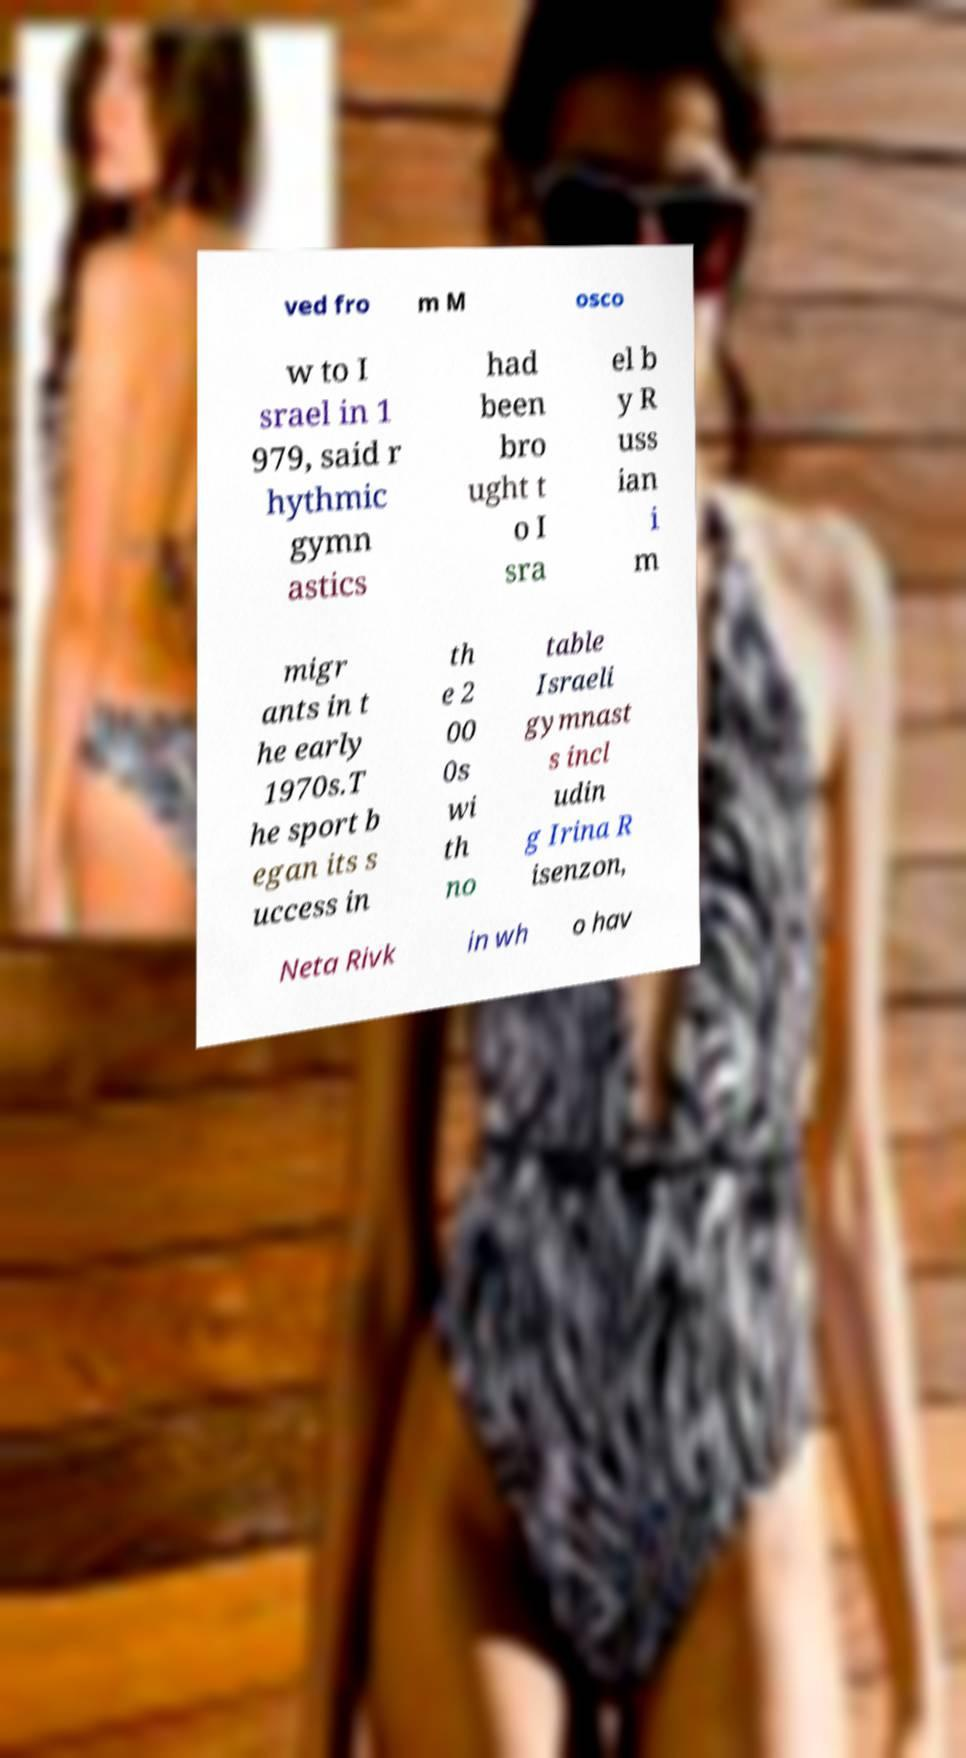Can you accurately transcribe the text from the provided image for me? ved fro m M osco w to I srael in 1 979, said r hythmic gymn astics had been bro ught t o I sra el b y R uss ian i m migr ants in t he early 1970s.T he sport b egan its s uccess in th e 2 00 0s wi th no table Israeli gymnast s incl udin g Irina R isenzon, Neta Rivk in wh o hav 